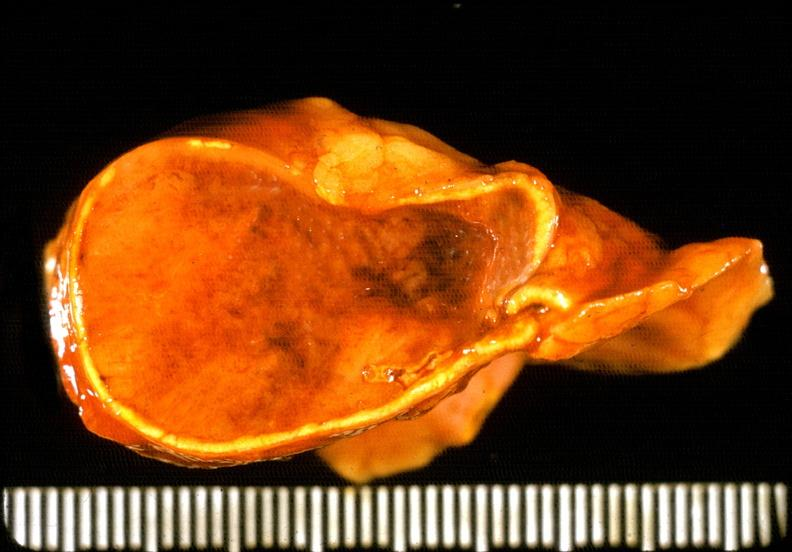what does this image show?
Answer the question using a single word or phrase. Adrenal phaeochromocytoma 